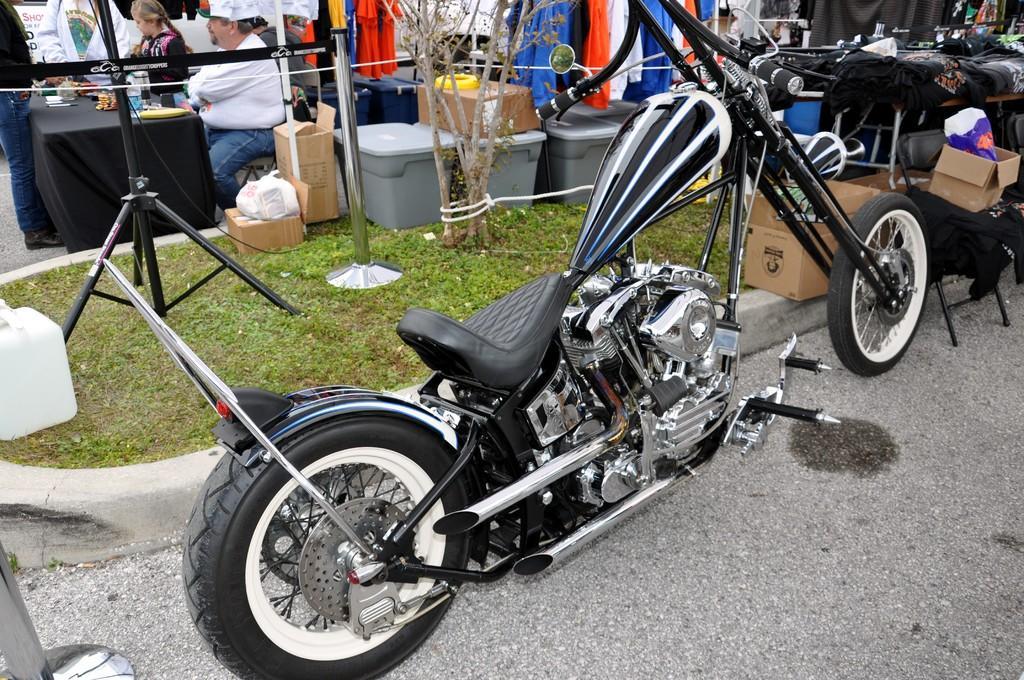In one or two sentences, can you explain what this image depicts? In this image, in the middle, we can see a vehicle which is placed on the road. On the right side, we can see some boxes and a table, on that table, we can also see a cloth which is in black color. In the left corner, we can see a pole. On the left side, we can see a metal rod, jars. On the left side, we can also see a group of people sitting on the chair in front of the table, on the table, we can see a black color cloth, we can also see some instrument on the table. On the left side, we can also see a person standing in front of the table. In the background, we can see some clothes, trees, pole. At the bottom, we can see a grass and a road. 